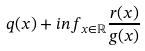<formula> <loc_0><loc_0><loc_500><loc_500>q ( x ) + i n f _ { x \in \mathbb { R } } \frac { r ( x ) } { g ( x ) }</formula> 